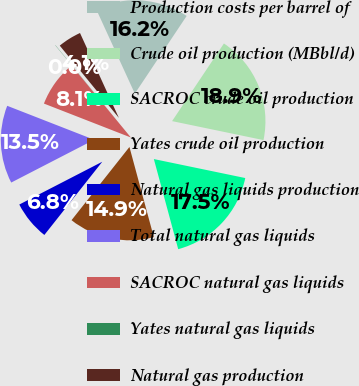Convert chart. <chart><loc_0><loc_0><loc_500><loc_500><pie_chart><fcel>Production costs per barrel of<fcel>Crude oil production (MBbl/d)<fcel>SACROC crude oil production<fcel>Yates crude oil production<fcel>Natural gas liquids production<fcel>Total natural gas liquids<fcel>SACROC natural gas liquids<fcel>Yates natural gas liquids<fcel>Natural gas production<nl><fcel>16.2%<fcel>18.89%<fcel>17.54%<fcel>14.85%<fcel>6.77%<fcel>13.5%<fcel>8.12%<fcel>0.04%<fcel>4.08%<nl></chart> 